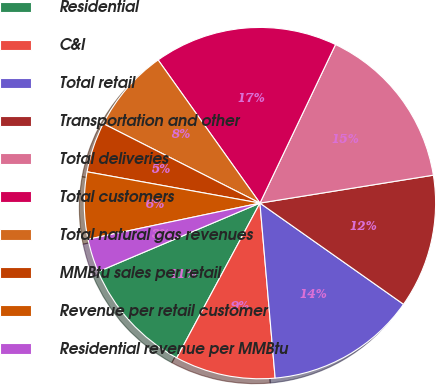Convert chart. <chart><loc_0><loc_0><loc_500><loc_500><pie_chart><fcel>Residential<fcel>C&I<fcel>Total retail<fcel>Transportation and other<fcel>Total deliveries<fcel>Total customers<fcel>Total natural gas revenues<fcel>MMBtu sales per retail<fcel>Revenue per retail customer<fcel>Residential revenue per MMBtu<nl><fcel>10.77%<fcel>9.23%<fcel>13.85%<fcel>12.31%<fcel>15.38%<fcel>16.92%<fcel>7.69%<fcel>4.62%<fcel>6.15%<fcel>3.08%<nl></chart> 